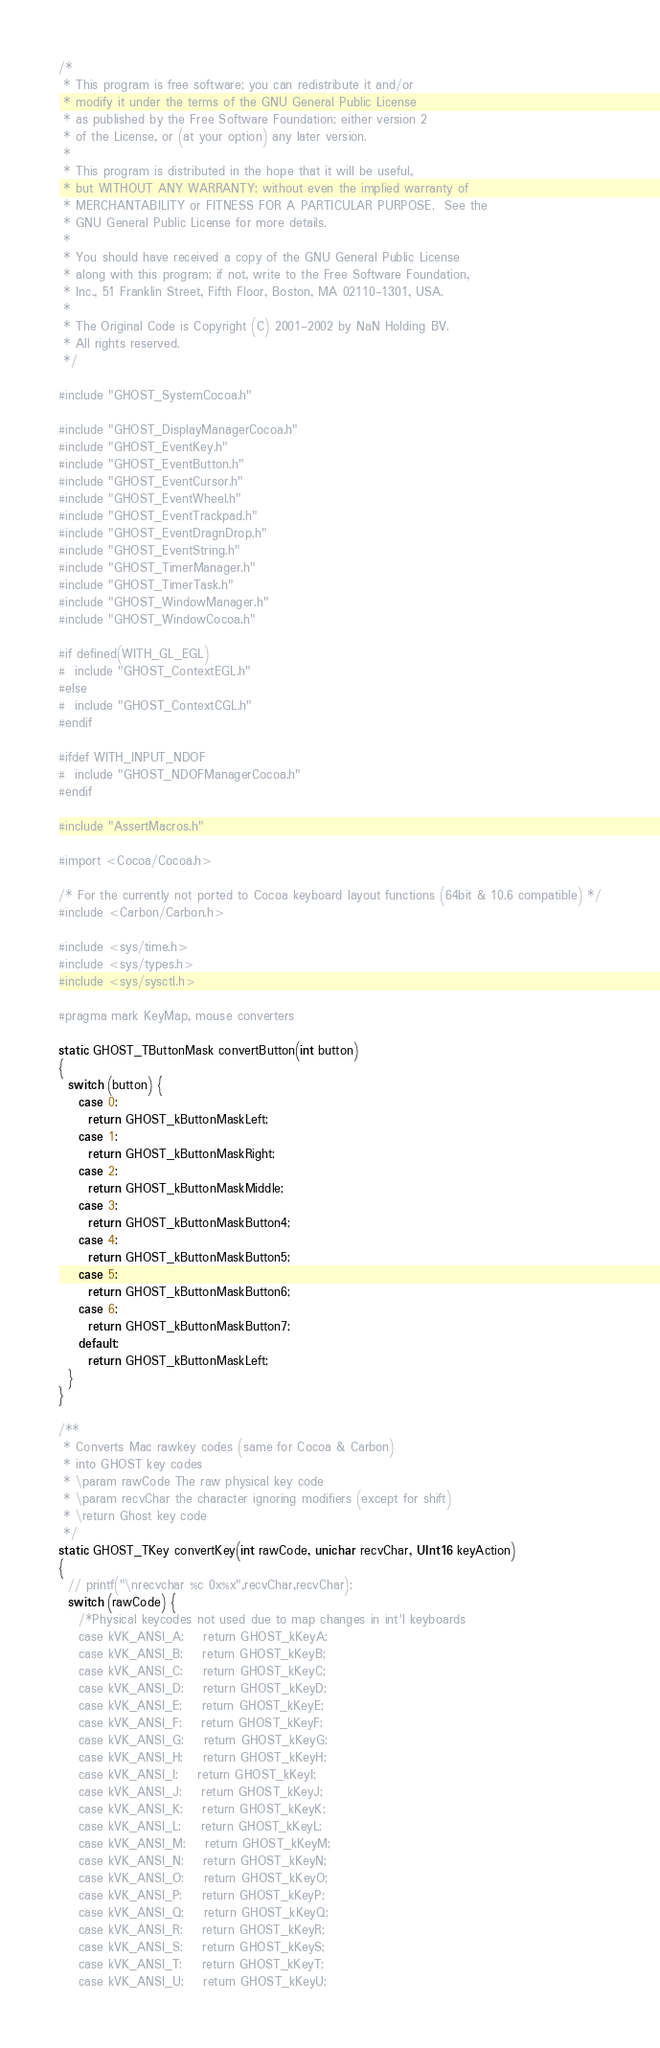<code> <loc_0><loc_0><loc_500><loc_500><_ObjectiveC_>/*
 * This program is free software; you can redistribute it and/or
 * modify it under the terms of the GNU General Public License
 * as published by the Free Software Foundation; either version 2
 * of the License, or (at your option) any later version.
 *
 * This program is distributed in the hope that it will be useful,
 * but WITHOUT ANY WARRANTY; without even the implied warranty of
 * MERCHANTABILITY or FITNESS FOR A PARTICULAR PURPOSE.  See the
 * GNU General Public License for more details.
 *
 * You should have received a copy of the GNU General Public License
 * along with this program; if not, write to the Free Software Foundation,
 * Inc., 51 Franklin Street, Fifth Floor, Boston, MA 02110-1301, USA.
 *
 * The Original Code is Copyright (C) 2001-2002 by NaN Holding BV.
 * All rights reserved.
 */

#include "GHOST_SystemCocoa.h"

#include "GHOST_DisplayManagerCocoa.h"
#include "GHOST_EventKey.h"
#include "GHOST_EventButton.h"
#include "GHOST_EventCursor.h"
#include "GHOST_EventWheel.h"
#include "GHOST_EventTrackpad.h"
#include "GHOST_EventDragnDrop.h"
#include "GHOST_EventString.h"
#include "GHOST_TimerManager.h"
#include "GHOST_TimerTask.h"
#include "GHOST_WindowManager.h"
#include "GHOST_WindowCocoa.h"

#if defined(WITH_GL_EGL)
#  include "GHOST_ContextEGL.h"
#else
#  include "GHOST_ContextCGL.h"
#endif

#ifdef WITH_INPUT_NDOF
#  include "GHOST_NDOFManagerCocoa.h"
#endif

#include "AssertMacros.h"

#import <Cocoa/Cocoa.h>

/* For the currently not ported to Cocoa keyboard layout functions (64bit & 10.6 compatible) */
#include <Carbon/Carbon.h>

#include <sys/time.h>
#include <sys/types.h>
#include <sys/sysctl.h>

#pragma mark KeyMap, mouse converters

static GHOST_TButtonMask convertButton(int button)
{
  switch (button) {
    case 0:
      return GHOST_kButtonMaskLeft;
    case 1:
      return GHOST_kButtonMaskRight;
    case 2:
      return GHOST_kButtonMaskMiddle;
    case 3:
      return GHOST_kButtonMaskButton4;
    case 4:
      return GHOST_kButtonMaskButton5;
    case 5:
      return GHOST_kButtonMaskButton6;
    case 6:
      return GHOST_kButtonMaskButton7;
    default:
      return GHOST_kButtonMaskLeft;
  }
}

/**
 * Converts Mac rawkey codes (same for Cocoa & Carbon)
 * into GHOST key codes
 * \param rawCode The raw physical key code
 * \param recvChar the character ignoring modifiers (except for shift)
 * \return Ghost key code
 */
static GHOST_TKey convertKey(int rawCode, unichar recvChar, UInt16 keyAction)
{
  // printf("\nrecvchar %c 0x%x",recvChar,recvChar);
  switch (rawCode) {
    /*Physical keycodes not used due to map changes in int'l keyboards
    case kVK_ANSI_A:    return GHOST_kKeyA;
    case kVK_ANSI_B:    return GHOST_kKeyB;
    case kVK_ANSI_C:    return GHOST_kKeyC;
    case kVK_ANSI_D:    return GHOST_kKeyD;
    case kVK_ANSI_E:    return GHOST_kKeyE;
    case kVK_ANSI_F:    return GHOST_kKeyF;
    case kVK_ANSI_G:    return GHOST_kKeyG;
    case kVK_ANSI_H:    return GHOST_kKeyH;
    case kVK_ANSI_I:    return GHOST_kKeyI;
    case kVK_ANSI_J:    return GHOST_kKeyJ;
    case kVK_ANSI_K:    return GHOST_kKeyK;
    case kVK_ANSI_L:    return GHOST_kKeyL;
    case kVK_ANSI_M:    return GHOST_kKeyM;
    case kVK_ANSI_N:    return GHOST_kKeyN;
    case kVK_ANSI_O:    return GHOST_kKeyO;
    case kVK_ANSI_P:    return GHOST_kKeyP;
    case kVK_ANSI_Q:    return GHOST_kKeyQ;
    case kVK_ANSI_R:    return GHOST_kKeyR;
    case kVK_ANSI_S:    return GHOST_kKeyS;
    case kVK_ANSI_T:    return GHOST_kKeyT;
    case kVK_ANSI_U:    return GHOST_kKeyU;</code> 